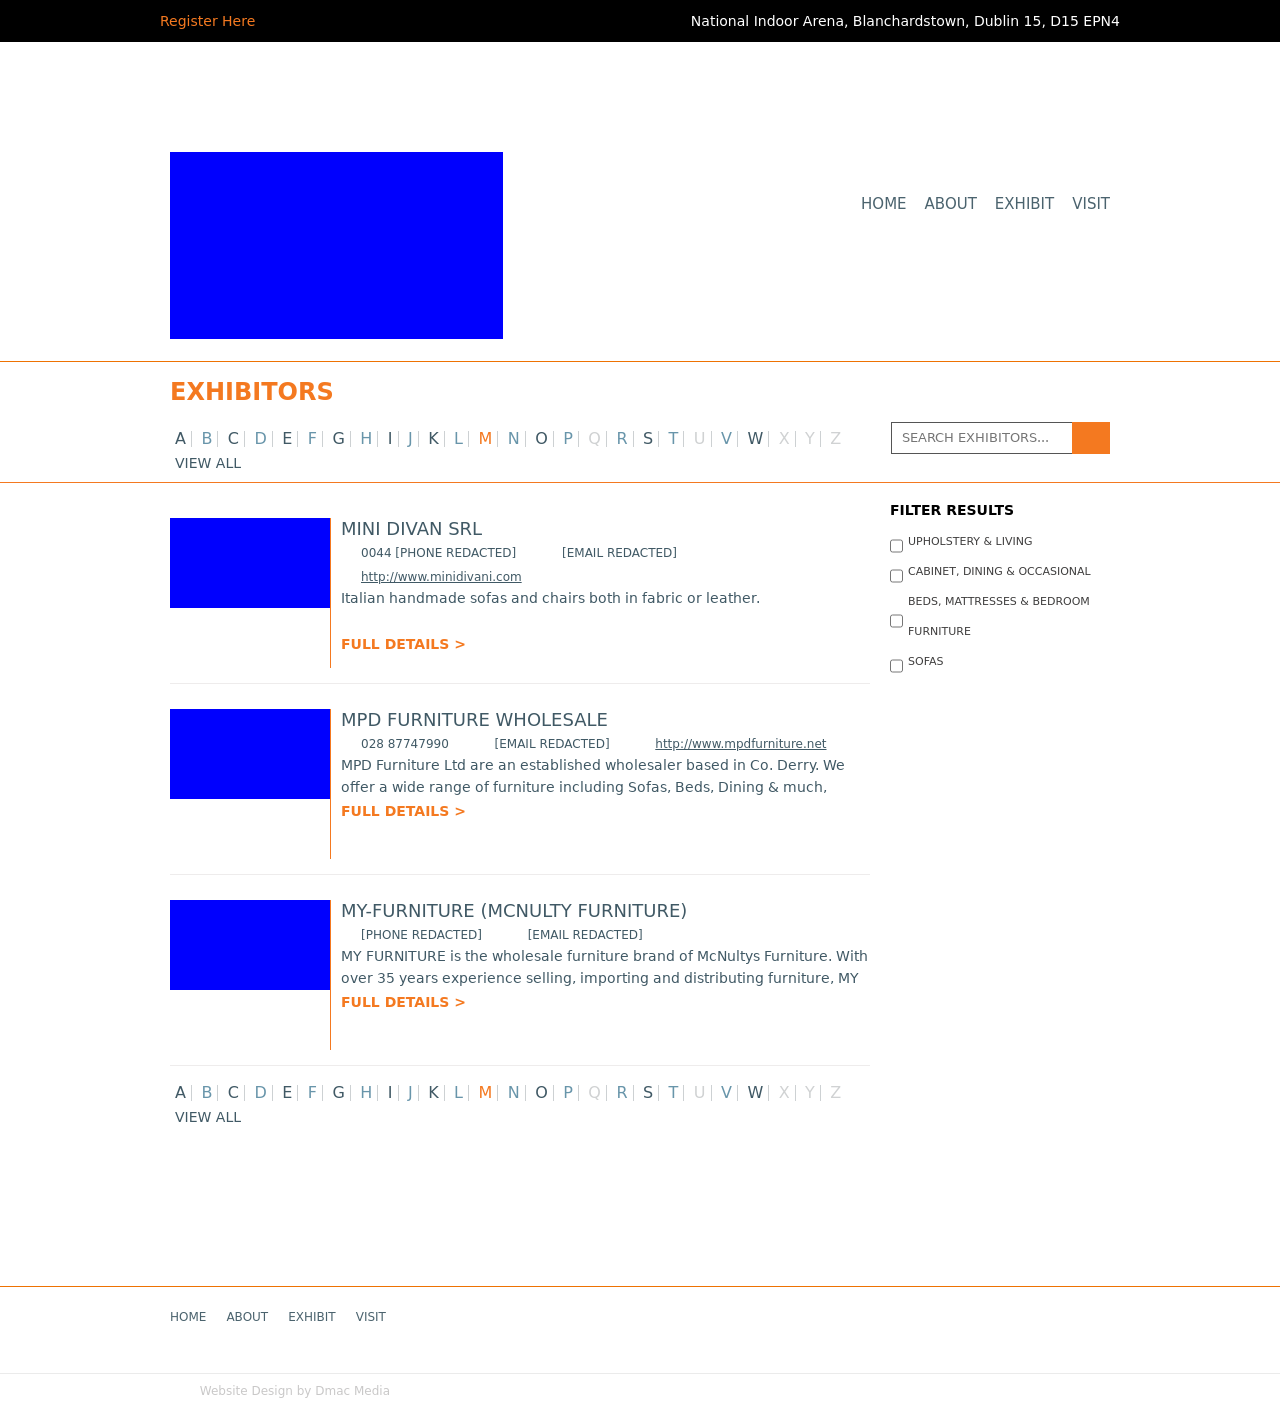How can I start building this website with HTML from the ground up? To start building a website that lists exhibitors, you would begin with the basic HTML structure as shown in the response. This structure includes sections like the header, footer, and main content area, where exhibitors' details can be displayed. Style the layout with CSS for a visually appealing and organized presentation. Include filtering functionality through JavaScript to allow users to search and filter exhibitors based on categories, which enhances user experience and accessibility of information. 